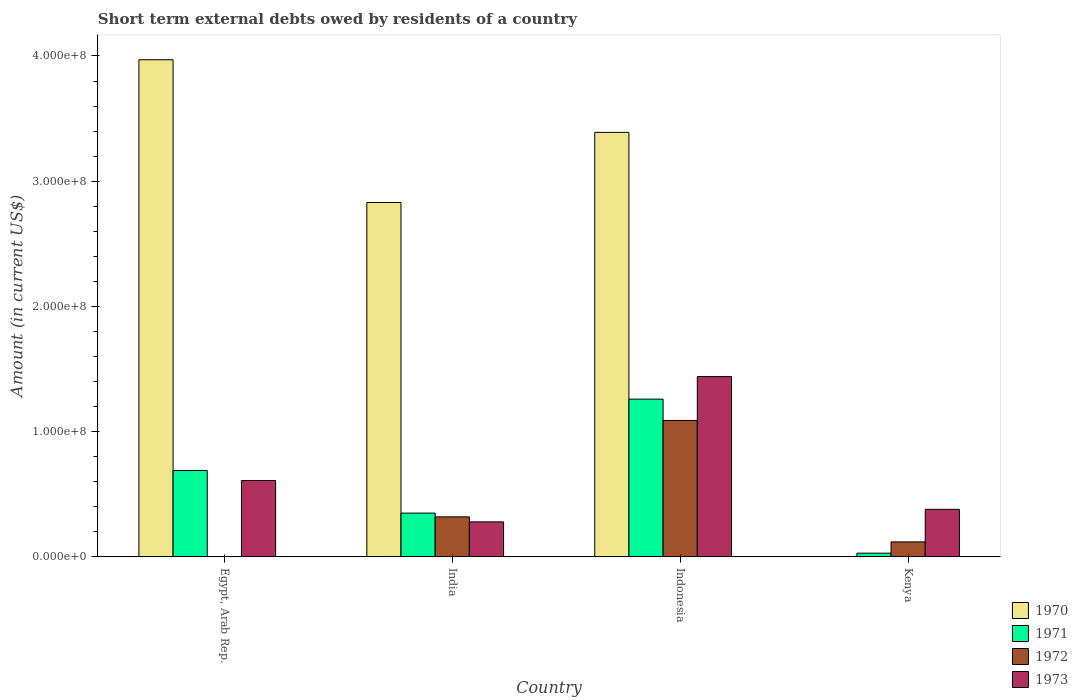How many different coloured bars are there?
Make the answer very short. 4. Are the number of bars per tick equal to the number of legend labels?
Ensure brevity in your answer.  No. How many bars are there on the 1st tick from the left?
Offer a very short reply. 3. What is the label of the 1st group of bars from the left?
Give a very brief answer. Egypt, Arab Rep. In how many cases, is the number of bars for a given country not equal to the number of legend labels?
Give a very brief answer. 2. What is the amount of short-term external debts owed by residents in 1970 in India?
Your response must be concise. 2.83e+08. Across all countries, what is the maximum amount of short-term external debts owed by residents in 1973?
Provide a short and direct response. 1.44e+08. In which country was the amount of short-term external debts owed by residents in 1970 maximum?
Offer a terse response. Egypt, Arab Rep. What is the total amount of short-term external debts owed by residents in 1973 in the graph?
Make the answer very short. 2.71e+08. What is the difference between the amount of short-term external debts owed by residents in 1973 in Kenya and the amount of short-term external debts owed by residents in 1970 in Egypt, Arab Rep.?
Keep it short and to the point. -3.59e+08. What is the average amount of short-term external debts owed by residents in 1972 per country?
Provide a short and direct response. 3.82e+07. What is the difference between the amount of short-term external debts owed by residents of/in 1973 and amount of short-term external debts owed by residents of/in 1971 in Kenya?
Offer a very short reply. 3.50e+07. In how many countries, is the amount of short-term external debts owed by residents in 1973 greater than 360000000 US$?
Keep it short and to the point. 0. What is the ratio of the amount of short-term external debts owed by residents in 1973 in Egypt, Arab Rep. to that in Indonesia?
Ensure brevity in your answer.  0.42. Is the amount of short-term external debts owed by residents in 1970 in India less than that in Indonesia?
Your answer should be compact. Yes. Is the difference between the amount of short-term external debts owed by residents in 1973 in India and Indonesia greater than the difference between the amount of short-term external debts owed by residents in 1971 in India and Indonesia?
Your response must be concise. No. What is the difference between the highest and the second highest amount of short-term external debts owed by residents in 1970?
Offer a terse response. 1.14e+08. What is the difference between the highest and the lowest amount of short-term external debts owed by residents in 1972?
Your answer should be compact. 1.09e+08. Is the sum of the amount of short-term external debts owed by residents in 1973 in Egypt, Arab Rep. and Kenya greater than the maximum amount of short-term external debts owed by residents in 1970 across all countries?
Give a very brief answer. No. Is it the case that in every country, the sum of the amount of short-term external debts owed by residents in 1972 and amount of short-term external debts owed by residents in 1971 is greater than the sum of amount of short-term external debts owed by residents in 1970 and amount of short-term external debts owed by residents in 1973?
Keep it short and to the point. No. Is it the case that in every country, the sum of the amount of short-term external debts owed by residents in 1973 and amount of short-term external debts owed by residents in 1972 is greater than the amount of short-term external debts owed by residents in 1971?
Your answer should be compact. No. Are all the bars in the graph horizontal?
Your answer should be very brief. No. How many countries are there in the graph?
Ensure brevity in your answer.  4. What is the difference between two consecutive major ticks on the Y-axis?
Your answer should be compact. 1.00e+08. Does the graph contain grids?
Offer a terse response. No. Where does the legend appear in the graph?
Make the answer very short. Bottom right. How are the legend labels stacked?
Your response must be concise. Vertical. What is the title of the graph?
Your response must be concise. Short term external debts owed by residents of a country. Does "2013" appear as one of the legend labels in the graph?
Your response must be concise. No. What is the label or title of the Y-axis?
Offer a terse response. Amount (in current US$). What is the Amount (in current US$) in 1970 in Egypt, Arab Rep.?
Make the answer very short. 3.97e+08. What is the Amount (in current US$) in 1971 in Egypt, Arab Rep.?
Your answer should be compact. 6.90e+07. What is the Amount (in current US$) of 1973 in Egypt, Arab Rep.?
Your answer should be very brief. 6.10e+07. What is the Amount (in current US$) in 1970 in India?
Your answer should be compact. 2.83e+08. What is the Amount (in current US$) of 1971 in India?
Offer a terse response. 3.50e+07. What is the Amount (in current US$) of 1972 in India?
Ensure brevity in your answer.  3.20e+07. What is the Amount (in current US$) of 1973 in India?
Make the answer very short. 2.80e+07. What is the Amount (in current US$) in 1970 in Indonesia?
Provide a short and direct response. 3.39e+08. What is the Amount (in current US$) of 1971 in Indonesia?
Provide a succinct answer. 1.26e+08. What is the Amount (in current US$) of 1972 in Indonesia?
Provide a succinct answer. 1.09e+08. What is the Amount (in current US$) in 1973 in Indonesia?
Make the answer very short. 1.44e+08. What is the Amount (in current US$) of 1971 in Kenya?
Your answer should be compact. 3.00e+06. What is the Amount (in current US$) of 1973 in Kenya?
Keep it short and to the point. 3.80e+07. Across all countries, what is the maximum Amount (in current US$) of 1970?
Provide a short and direct response. 3.97e+08. Across all countries, what is the maximum Amount (in current US$) in 1971?
Offer a very short reply. 1.26e+08. Across all countries, what is the maximum Amount (in current US$) of 1972?
Offer a very short reply. 1.09e+08. Across all countries, what is the maximum Amount (in current US$) in 1973?
Offer a terse response. 1.44e+08. Across all countries, what is the minimum Amount (in current US$) in 1971?
Your answer should be very brief. 3.00e+06. Across all countries, what is the minimum Amount (in current US$) in 1972?
Your response must be concise. 0. Across all countries, what is the minimum Amount (in current US$) of 1973?
Provide a short and direct response. 2.80e+07. What is the total Amount (in current US$) of 1970 in the graph?
Keep it short and to the point. 1.02e+09. What is the total Amount (in current US$) in 1971 in the graph?
Your answer should be compact. 2.33e+08. What is the total Amount (in current US$) in 1972 in the graph?
Keep it short and to the point. 1.53e+08. What is the total Amount (in current US$) in 1973 in the graph?
Provide a succinct answer. 2.71e+08. What is the difference between the Amount (in current US$) in 1970 in Egypt, Arab Rep. and that in India?
Keep it short and to the point. 1.14e+08. What is the difference between the Amount (in current US$) of 1971 in Egypt, Arab Rep. and that in India?
Provide a succinct answer. 3.40e+07. What is the difference between the Amount (in current US$) in 1973 in Egypt, Arab Rep. and that in India?
Ensure brevity in your answer.  3.30e+07. What is the difference between the Amount (in current US$) in 1970 in Egypt, Arab Rep. and that in Indonesia?
Your answer should be compact. 5.80e+07. What is the difference between the Amount (in current US$) in 1971 in Egypt, Arab Rep. and that in Indonesia?
Provide a succinct answer. -5.70e+07. What is the difference between the Amount (in current US$) in 1973 in Egypt, Arab Rep. and that in Indonesia?
Offer a very short reply. -8.30e+07. What is the difference between the Amount (in current US$) in 1971 in Egypt, Arab Rep. and that in Kenya?
Offer a terse response. 6.60e+07. What is the difference between the Amount (in current US$) of 1973 in Egypt, Arab Rep. and that in Kenya?
Give a very brief answer. 2.30e+07. What is the difference between the Amount (in current US$) of 1970 in India and that in Indonesia?
Provide a short and direct response. -5.60e+07. What is the difference between the Amount (in current US$) in 1971 in India and that in Indonesia?
Provide a succinct answer. -9.10e+07. What is the difference between the Amount (in current US$) in 1972 in India and that in Indonesia?
Your answer should be very brief. -7.70e+07. What is the difference between the Amount (in current US$) of 1973 in India and that in Indonesia?
Offer a terse response. -1.16e+08. What is the difference between the Amount (in current US$) of 1971 in India and that in Kenya?
Keep it short and to the point. 3.20e+07. What is the difference between the Amount (in current US$) in 1973 in India and that in Kenya?
Your response must be concise. -1.00e+07. What is the difference between the Amount (in current US$) in 1971 in Indonesia and that in Kenya?
Provide a short and direct response. 1.23e+08. What is the difference between the Amount (in current US$) of 1972 in Indonesia and that in Kenya?
Make the answer very short. 9.70e+07. What is the difference between the Amount (in current US$) in 1973 in Indonesia and that in Kenya?
Your response must be concise. 1.06e+08. What is the difference between the Amount (in current US$) of 1970 in Egypt, Arab Rep. and the Amount (in current US$) of 1971 in India?
Your answer should be compact. 3.62e+08. What is the difference between the Amount (in current US$) in 1970 in Egypt, Arab Rep. and the Amount (in current US$) in 1972 in India?
Give a very brief answer. 3.65e+08. What is the difference between the Amount (in current US$) of 1970 in Egypt, Arab Rep. and the Amount (in current US$) of 1973 in India?
Offer a terse response. 3.69e+08. What is the difference between the Amount (in current US$) of 1971 in Egypt, Arab Rep. and the Amount (in current US$) of 1972 in India?
Ensure brevity in your answer.  3.70e+07. What is the difference between the Amount (in current US$) in 1971 in Egypt, Arab Rep. and the Amount (in current US$) in 1973 in India?
Keep it short and to the point. 4.10e+07. What is the difference between the Amount (in current US$) in 1970 in Egypt, Arab Rep. and the Amount (in current US$) in 1971 in Indonesia?
Keep it short and to the point. 2.71e+08. What is the difference between the Amount (in current US$) of 1970 in Egypt, Arab Rep. and the Amount (in current US$) of 1972 in Indonesia?
Provide a succinct answer. 2.88e+08. What is the difference between the Amount (in current US$) of 1970 in Egypt, Arab Rep. and the Amount (in current US$) of 1973 in Indonesia?
Keep it short and to the point. 2.53e+08. What is the difference between the Amount (in current US$) of 1971 in Egypt, Arab Rep. and the Amount (in current US$) of 1972 in Indonesia?
Provide a succinct answer. -4.00e+07. What is the difference between the Amount (in current US$) of 1971 in Egypt, Arab Rep. and the Amount (in current US$) of 1973 in Indonesia?
Offer a terse response. -7.50e+07. What is the difference between the Amount (in current US$) in 1970 in Egypt, Arab Rep. and the Amount (in current US$) in 1971 in Kenya?
Offer a very short reply. 3.94e+08. What is the difference between the Amount (in current US$) of 1970 in Egypt, Arab Rep. and the Amount (in current US$) of 1972 in Kenya?
Your answer should be compact. 3.85e+08. What is the difference between the Amount (in current US$) of 1970 in Egypt, Arab Rep. and the Amount (in current US$) of 1973 in Kenya?
Offer a terse response. 3.59e+08. What is the difference between the Amount (in current US$) in 1971 in Egypt, Arab Rep. and the Amount (in current US$) in 1972 in Kenya?
Offer a very short reply. 5.70e+07. What is the difference between the Amount (in current US$) of 1971 in Egypt, Arab Rep. and the Amount (in current US$) of 1973 in Kenya?
Offer a terse response. 3.10e+07. What is the difference between the Amount (in current US$) in 1970 in India and the Amount (in current US$) in 1971 in Indonesia?
Provide a short and direct response. 1.57e+08. What is the difference between the Amount (in current US$) of 1970 in India and the Amount (in current US$) of 1972 in Indonesia?
Keep it short and to the point. 1.74e+08. What is the difference between the Amount (in current US$) in 1970 in India and the Amount (in current US$) in 1973 in Indonesia?
Your response must be concise. 1.39e+08. What is the difference between the Amount (in current US$) in 1971 in India and the Amount (in current US$) in 1972 in Indonesia?
Keep it short and to the point. -7.40e+07. What is the difference between the Amount (in current US$) in 1971 in India and the Amount (in current US$) in 1973 in Indonesia?
Provide a short and direct response. -1.09e+08. What is the difference between the Amount (in current US$) of 1972 in India and the Amount (in current US$) of 1973 in Indonesia?
Ensure brevity in your answer.  -1.12e+08. What is the difference between the Amount (in current US$) of 1970 in India and the Amount (in current US$) of 1971 in Kenya?
Ensure brevity in your answer.  2.80e+08. What is the difference between the Amount (in current US$) in 1970 in India and the Amount (in current US$) in 1972 in Kenya?
Make the answer very short. 2.71e+08. What is the difference between the Amount (in current US$) in 1970 in India and the Amount (in current US$) in 1973 in Kenya?
Ensure brevity in your answer.  2.45e+08. What is the difference between the Amount (in current US$) of 1971 in India and the Amount (in current US$) of 1972 in Kenya?
Ensure brevity in your answer.  2.30e+07. What is the difference between the Amount (in current US$) of 1972 in India and the Amount (in current US$) of 1973 in Kenya?
Your answer should be very brief. -6.00e+06. What is the difference between the Amount (in current US$) of 1970 in Indonesia and the Amount (in current US$) of 1971 in Kenya?
Offer a very short reply. 3.36e+08. What is the difference between the Amount (in current US$) in 1970 in Indonesia and the Amount (in current US$) in 1972 in Kenya?
Offer a very short reply. 3.27e+08. What is the difference between the Amount (in current US$) of 1970 in Indonesia and the Amount (in current US$) of 1973 in Kenya?
Keep it short and to the point. 3.01e+08. What is the difference between the Amount (in current US$) in 1971 in Indonesia and the Amount (in current US$) in 1972 in Kenya?
Your answer should be compact. 1.14e+08. What is the difference between the Amount (in current US$) in 1971 in Indonesia and the Amount (in current US$) in 1973 in Kenya?
Provide a short and direct response. 8.80e+07. What is the difference between the Amount (in current US$) of 1972 in Indonesia and the Amount (in current US$) of 1973 in Kenya?
Your answer should be very brief. 7.10e+07. What is the average Amount (in current US$) of 1970 per country?
Give a very brief answer. 2.55e+08. What is the average Amount (in current US$) of 1971 per country?
Offer a terse response. 5.82e+07. What is the average Amount (in current US$) in 1972 per country?
Provide a short and direct response. 3.82e+07. What is the average Amount (in current US$) of 1973 per country?
Provide a short and direct response. 6.78e+07. What is the difference between the Amount (in current US$) in 1970 and Amount (in current US$) in 1971 in Egypt, Arab Rep.?
Provide a short and direct response. 3.28e+08. What is the difference between the Amount (in current US$) of 1970 and Amount (in current US$) of 1973 in Egypt, Arab Rep.?
Ensure brevity in your answer.  3.36e+08. What is the difference between the Amount (in current US$) of 1970 and Amount (in current US$) of 1971 in India?
Make the answer very short. 2.48e+08. What is the difference between the Amount (in current US$) in 1970 and Amount (in current US$) in 1972 in India?
Offer a terse response. 2.51e+08. What is the difference between the Amount (in current US$) in 1970 and Amount (in current US$) in 1973 in India?
Make the answer very short. 2.55e+08. What is the difference between the Amount (in current US$) of 1971 and Amount (in current US$) of 1973 in India?
Give a very brief answer. 7.00e+06. What is the difference between the Amount (in current US$) in 1972 and Amount (in current US$) in 1973 in India?
Give a very brief answer. 4.00e+06. What is the difference between the Amount (in current US$) of 1970 and Amount (in current US$) of 1971 in Indonesia?
Ensure brevity in your answer.  2.13e+08. What is the difference between the Amount (in current US$) in 1970 and Amount (in current US$) in 1972 in Indonesia?
Ensure brevity in your answer.  2.30e+08. What is the difference between the Amount (in current US$) in 1970 and Amount (in current US$) in 1973 in Indonesia?
Offer a very short reply. 1.95e+08. What is the difference between the Amount (in current US$) of 1971 and Amount (in current US$) of 1972 in Indonesia?
Provide a short and direct response. 1.70e+07. What is the difference between the Amount (in current US$) of 1971 and Amount (in current US$) of 1973 in Indonesia?
Provide a succinct answer. -1.80e+07. What is the difference between the Amount (in current US$) in 1972 and Amount (in current US$) in 1973 in Indonesia?
Keep it short and to the point. -3.50e+07. What is the difference between the Amount (in current US$) of 1971 and Amount (in current US$) of 1972 in Kenya?
Your answer should be compact. -9.00e+06. What is the difference between the Amount (in current US$) in 1971 and Amount (in current US$) in 1973 in Kenya?
Make the answer very short. -3.50e+07. What is the difference between the Amount (in current US$) in 1972 and Amount (in current US$) in 1973 in Kenya?
Your answer should be compact. -2.60e+07. What is the ratio of the Amount (in current US$) in 1970 in Egypt, Arab Rep. to that in India?
Offer a very short reply. 1.4. What is the ratio of the Amount (in current US$) of 1971 in Egypt, Arab Rep. to that in India?
Provide a succinct answer. 1.97. What is the ratio of the Amount (in current US$) of 1973 in Egypt, Arab Rep. to that in India?
Your answer should be very brief. 2.18. What is the ratio of the Amount (in current US$) in 1970 in Egypt, Arab Rep. to that in Indonesia?
Your answer should be compact. 1.17. What is the ratio of the Amount (in current US$) in 1971 in Egypt, Arab Rep. to that in Indonesia?
Your response must be concise. 0.55. What is the ratio of the Amount (in current US$) of 1973 in Egypt, Arab Rep. to that in Indonesia?
Your answer should be very brief. 0.42. What is the ratio of the Amount (in current US$) in 1973 in Egypt, Arab Rep. to that in Kenya?
Make the answer very short. 1.61. What is the ratio of the Amount (in current US$) of 1970 in India to that in Indonesia?
Offer a very short reply. 0.83. What is the ratio of the Amount (in current US$) of 1971 in India to that in Indonesia?
Give a very brief answer. 0.28. What is the ratio of the Amount (in current US$) of 1972 in India to that in Indonesia?
Offer a terse response. 0.29. What is the ratio of the Amount (in current US$) in 1973 in India to that in Indonesia?
Give a very brief answer. 0.19. What is the ratio of the Amount (in current US$) of 1971 in India to that in Kenya?
Your response must be concise. 11.67. What is the ratio of the Amount (in current US$) of 1972 in India to that in Kenya?
Offer a terse response. 2.67. What is the ratio of the Amount (in current US$) in 1973 in India to that in Kenya?
Your answer should be very brief. 0.74. What is the ratio of the Amount (in current US$) of 1972 in Indonesia to that in Kenya?
Provide a succinct answer. 9.08. What is the ratio of the Amount (in current US$) of 1973 in Indonesia to that in Kenya?
Make the answer very short. 3.79. What is the difference between the highest and the second highest Amount (in current US$) in 1970?
Provide a succinct answer. 5.80e+07. What is the difference between the highest and the second highest Amount (in current US$) in 1971?
Offer a terse response. 5.70e+07. What is the difference between the highest and the second highest Amount (in current US$) of 1972?
Provide a short and direct response. 7.70e+07. What is the difference between the highest and the second highest Amount (in current US$) in 1973?
Give a very brief answer. 8.30e+07. What is the difference between the highest and the lowest Amount (in current US$) in 1970?
Offer a terse response. 3.97e+08. What is the difference between the highest and the lowest Amount (in current US$) of 1971?
Give a very brief answer. 1.23e+08. What is the difference between the highest and the lowest Amount (in current US$) in 1972?
Your response must be concise. 1.09e+08. What is the difference between the highest and the lowest Amount (in current US$) of 1973?
Keep it short and to the point. 1.16e+08. 